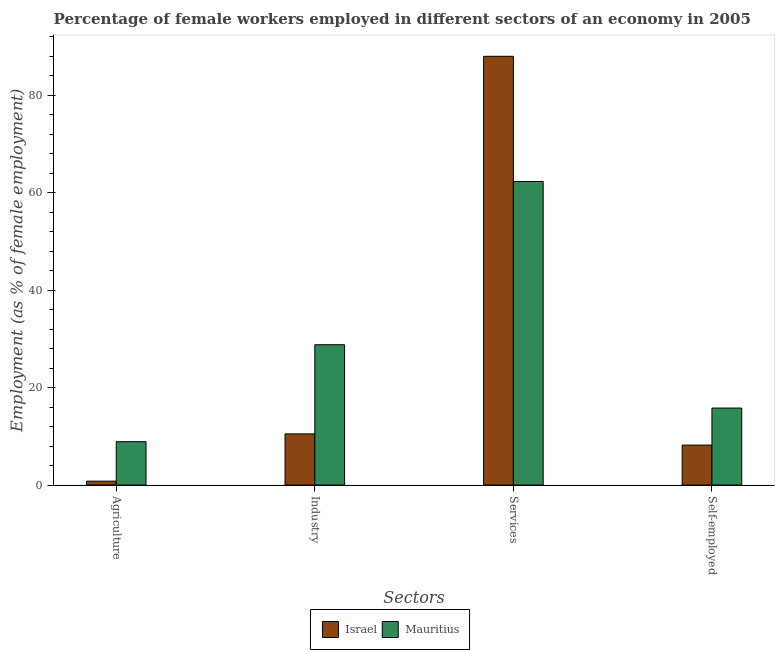How many groups of bars are there?
Provide a short and direct response. 4. Are the number of bars per tick equal to the number of legend labels?
Ensure brevity in your answer.  Yes. Are the number of bars on each tick of the X-axis equal?
Give a very brief answer. Yes. What is the label of the 4th group of bars from the left?
Your answer should be compact. Self-employed. What is the percentage of female workers in industry in Israel?
Make the answer very short. 10.5. Across all countries, what is the maximum percentage of self employed female workers?
Give a very brief answer. 15.8. Across all countries, what is the minimum percentage of self employed female workers?
Offer a very short reply. 8.2. In which country was the percentage of female workers in services minimum?
Your response must be concise. Mauritius. What is the total percentage of female workers in agriculture in the graph?
Your answer should be compact. 9.7. What is the difference between the percentage of female workers in agriculture in Mauritius and that in Israel?
Ensure brevity in your answer.  8.1. What is the difference between the percentage of female workers in agriculture in Israel and the percentage of female workers in industry in Mauritius?
Provide a short and direct response. -28. What is the average percentage of self employed female workers per country?
Your response must be concise. 12. What is the difference between the percentage of self employed female workers and percentage of female workers in agriculture in Israel?
Provide a succinct answer. 7.4. What is the ratio of the percentage of female workers in agriculture in Israel to that in Mauritius?
Offer a terse response. 0.09. Is the difference between the percentage of female workers in agriculture in Mauritius and Israel greater than the difference between the percentage of female workers in industry in Mauritius and Israel?
Your answer should be very brief. No. What is the difference between the highest and the second highest percentage of self employed female workers?
Ensure brevity in your answer.  7.6. What is the difference between the highest and the lowest percentage of female workers in services?
Offer a terse response. 25.7. Is it the case that in every country, the sum of the percentage of female workers in services and percentage of self employed female workers is greater than the sum of percentage of female workers in industry and percentage of female workers in agriculture?
Keep it short and to the point. Yes. What does the 1st bar from the left in Services represents?
Ensure brevity in your answer.  Israel. What does the 2nd bar from the right in Services represents?
Your answer should be very brief. Israel. Are all the bars in the graph horizontal?
Your answer should be compact. No. Does the graph contain grids?
Ensure brevity in your answer.  No. How are the legend labels stacked?
Your answer should be compact. Horizontal. What is the title of the graph?
Your answer should be very brief. Percentage of female workers employed in different sectors of an economy in 2005. What is the label or title of the X-axis?
Your answer should be compact. Sectors. What is the label or title of the Y-axis?
Your answer should be very brief. Employment (as % of female employment). What is the Employment (as % of female employment) of Israel in Agriculture?
Offer a very short reply. 0.8. What is the Employment (as % of female employment) in Mauritius in Agriculture?
Give a very brief answer. 8.9. What is the Employment (as % of female employment) in Mauritius in Industry?
Offer a terse response. 28.8. What is the Employment (as % of female employment) in Mauritius in Services?
Ensure brevity in your answer.  62.3. What is the Employment (as % of female employment) of Israel in Self-employed?
Give a very brief answer. 8.2. What is the Employment (as % of female employment) of Mauritius in Self-employed?
Your answer should be very brief. 15.8. Across all Sectors, what is the maximum Employment (as % of female employment) of Israel?
Provide a short and direct response. 88. Across all Sectors, what is the maximum Employment (as % of female employment) of Mauritius?
Your answer should be compact. 62.3. Across all Sectors, what is the minimum Employment (as % of female employment) of Israel?
Ensure brevity in your answer.  0.8. Across all Sectors, what is the minimum Employment (as % of female employment) of Mauritius?
Your response must be concise. 8.9. What is the total Employment (as % of female employment) of Israel in the graph?
Your response must be concise. 107.5. What is the total Employment (as % of female employment) in Mauritius in the graph?
Keep it short and to the point. 115.8. What is the difference between the Employment (as % of female employment) in Israel in Agriculture and that in Industry?
Give a very brief answer. -9.7. What is the difference between the Employment (as % of female employment) in Mauritius in Agriculture and that in Industry?
Your answer should be very brief. -19.9. What is the difference between the Employment (as % of female employment) of Israel in Agriculture and that in Services?
Ensure brevity in your answer.  -87.2. What is the difference between the Employment (as % of female employment) in Mauritius in Agriculture and that in Services?
Keep it short and to the point. -53.4. What is the difference between the Employment (as % of female employment) in Israel in Agriculture and that in Self-employed?
Provide a succinct answer. -7.4. What is the difference between the Employment (as % of female employment) of Mauritius in Agriculture and that in Self-employed?
Give a very brief answer. -6.9. What is the difference between the Employment (as % of female employment) in Israel in Industry and that in Services?
Ensure brevity in your answer.  -77.5. What is the difference between the Employment (as % of female employment) in Mauritius in Industry and that in Services?
Provide a succinct answer. -33.5. What is the difference between the Employment (as % of female employment) in Israel in Industry and that in Self-employed?
Your answer should be compact. 2.3. What is the difference between the Employment (as % of female employment) of Mauritius in Industry and that in Self-employed?
Provide a succinct answer. 13. What is the difference between the Employment (as % of female employment) of Israel in Services and that in Self-employed?
Give a very brief answer. 79.8. What is the difference between the Employment (as % of female employment) in Mauritius in Services and that in Self-employed?
Offer a very short reply. 46.5. What is the difference between the Employment (as % of female employment) of Israel in Agriculture and the Employment (as % of female employment) of Mauritius in Services?
Provide a short and direct response. -61.5. What is the difference between the Employment (as % of female employment) in Israel in Agriculture and the Employment (as % of female employment) in Mauritius in Self-employed?
Your response must be concise. -15. What is the difference between the Employment (as % of female employment) of Israel in Industry and the Employment (as % of female employment) of Mauritius in Services?
Ensure brevity in your answer.  -51.8. What is the difference between the Employment (as % of female employment) of Israel in Industry and the Employment (as % of female employment) of Mauritius in Self-employed?
Your response must be concise. -5.3. What is the difference between the Employment (as % of female employment) of Israel in Services and the Employment (as % of female employment) of Mauritius in Self-employed?
Keep it short and to the point. 72.2. What is the average Employment (as % of female employment) of Israel per Sectors?
Give a very brief answer. 26.88. What is the average Employment (as % of female employment) in Mauritius per Sectors?
Provide a short and direct response. 28.95. What is the difference between the Employment (as % of female employment) of Israel and Employment (as % of female employment) of Mauritius in Industry?
Give a very brief answer. -18.3. What is the difference between the Employment (as % of female employment) of Israel and Employment (as % of female employment) of Mauritius in Services?
Offer a very short reply. 25.7. What is the difference between the Employment (as % of female employment) in Israel and Employment (as % of female employment) in Mauritius in Self-employed?
Ensure brevity in your answer.  -7.6. What is the ratio of the Employment (as % of female employment) in Israel in Agriculture to that in Industry?
Offer a terse response. 0.08. What is the ratio of the Employment (as % of female employment) of Mauritius in Agriculture to that in Industry?
Give a very brief answer. 0.31. What is the ratio of the Employment (as % of female employment) in Israel in Agriculture to that in Services?
Provide a succinct answer. 0.01. What is the ratio of the Employment (as % of female employment) in Mauritius in Agriculture to that in Services?
Your answer should be compact. 0.14. What is the ratio of the Employment (as % of female employment) of Israel in Agriculture to that in Self-employed?
Give a very brief answer. 0.1. What is the ratio of the Employment (as % of female employment) of Mauritius in Agriculture to that in Self-employed?
Keep it short and to the point. 0.56. What is the ratio of the Employment (as % of female employment) in Israel in Industry to that in Services?
Your response must be concise. 0.12. What is the ratio of the Employment (as % of female employment) in Mauritius in Industry to that in Services?
Your response must be concise. 0.46. What is the ratio of the Employment (as % of female employment) of Israel in Industry to that in Self-employed?
Provide a succinct answer. 1.28. What is the ratio of the Employment (as % of female employment) of Mauritius in Industry to that in Self-employed?
Your response must be concise. 1.82. What is the ratio of the Employment (as % of female employment) of Israel in Services to that in Self-employed?
Your answer should be very brief. 10.73. What is the ratio of the Employment (as % of female employment) of Mauritius in Services to that in Self-employed?
Keep it short and to the point. 3.94. What is the difference between the highest and the second highest Employment (as % of female employment) of Israel?
Your answer should be compact. 77.5. What is the difference between the highest and the second highest Employment (as % of female employment) in Mauritius?
Offer a terse response. 33.5. What is the difference between the highest and the lowest Employment (as % of female employment) of Israel?
Provide a short and direct response. 87.2. What is the difference between the highest and the lowest Employment (as % of female employment) in Mauritius?
Provide a succinct answer. 53.4. 